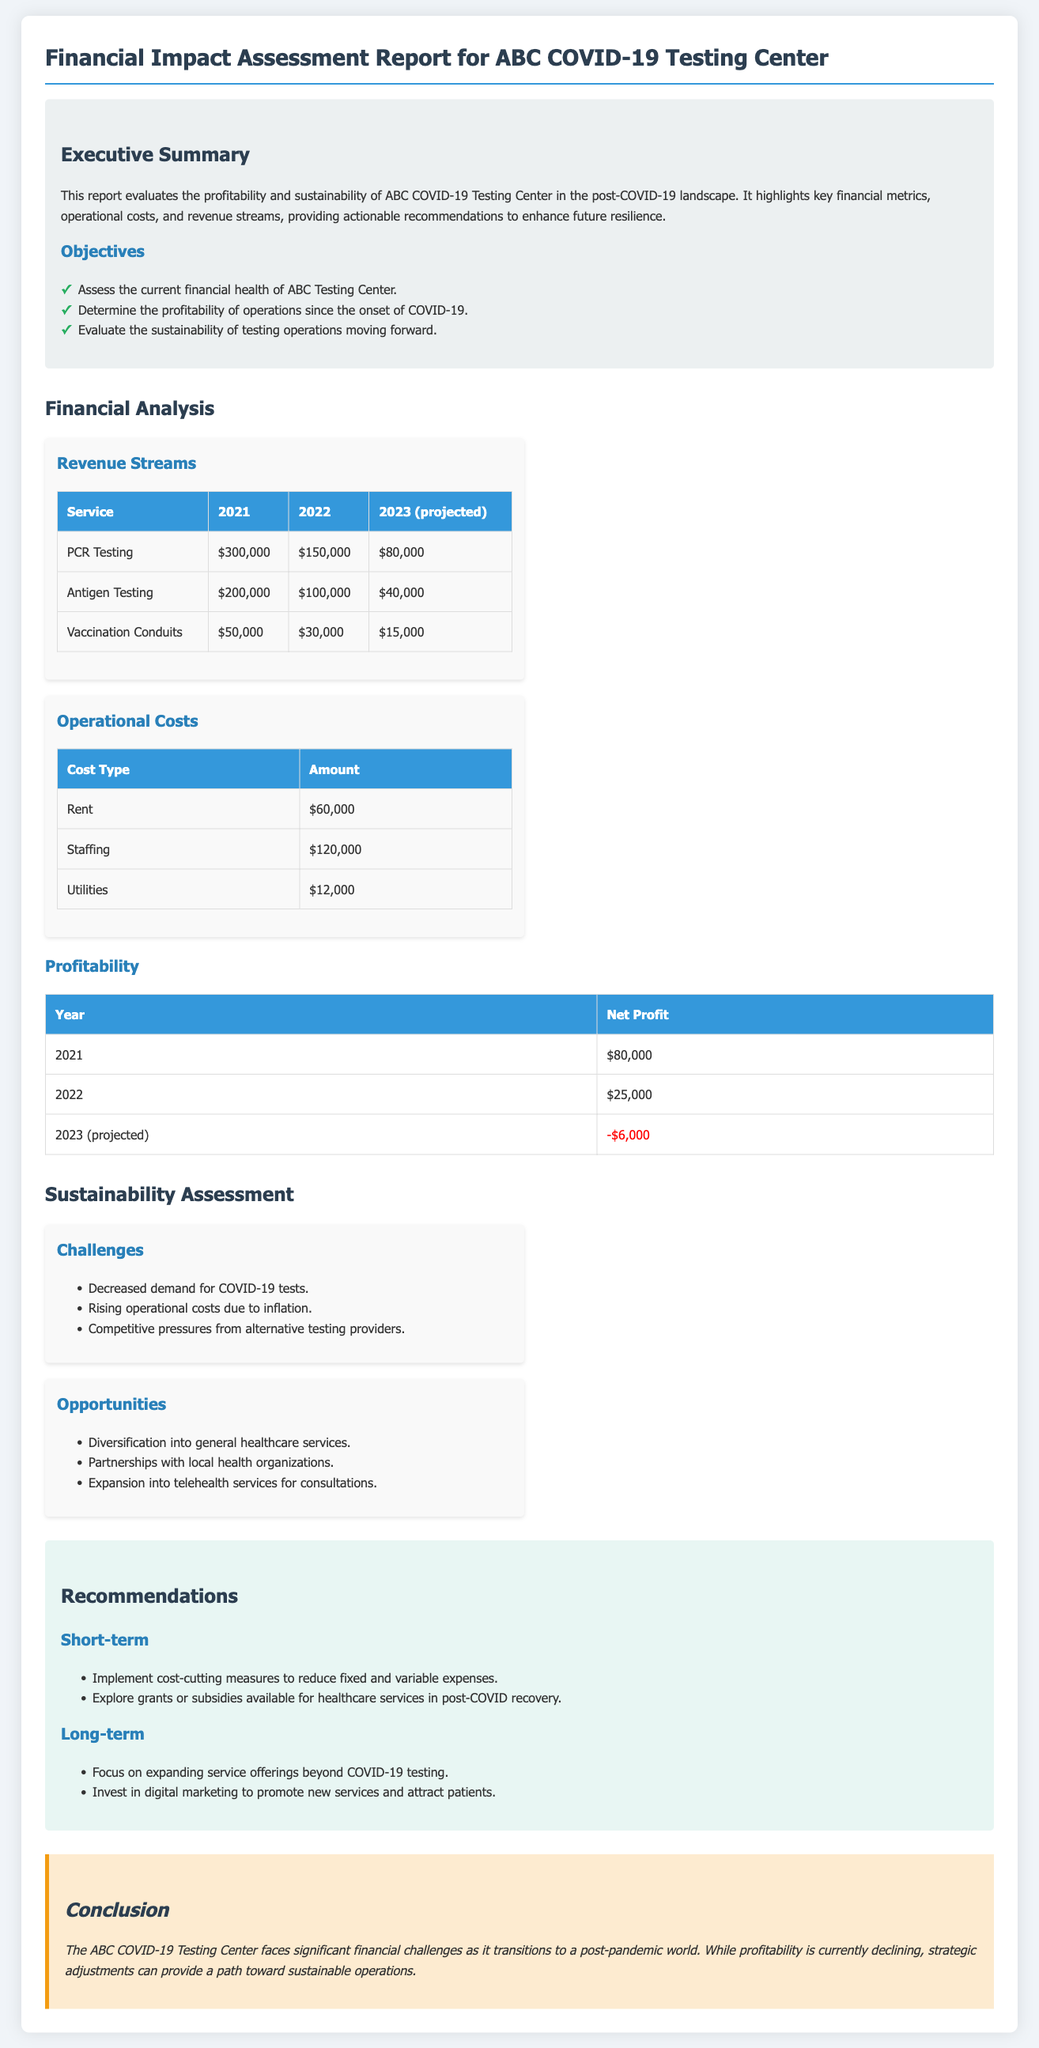what is the net profit for 2021? The net profit for 2021 is directly stated in the document as $80,000.
Answer: $80,000 what was the revenue from PCR testing in 2022? The document provides the revenue from PCR testing for 2022 as $150,000.
Answer: $150,000 what are two identified challenges for sustainability? The document lists challenges such as "Decreased demand for COVID-19 tests" and "Rising operational costs due to inflation".
Answer: Decreased demand for COVID-19 tests, Rising operational costs due to inflation what is the total staffing cost? The staffing cost is given explicitly as $120,000 in the operational costs section of the report.
Answer: $120,000 what is the projected net profit for 2023? The projected net profit for 2023 is indicated as -$6,000, highlighting a loss.
Answer: -$6,000 what are short-term recommendations listed in the report? The report includes recommendations such as "Implement cost-cutting measures" and "Explore grants or subsidies".
Answer: Implement cost-cutting measures, Explore grants or subsidies what is the total revenue from Antigen Testing in 2023? The revenue from Antigen Testing in 2023 is specified as $40,000 in the revenue streams table.
Answer: $40,000 what is the year-over-year trend in net profit from 2021 to 2023? The trend indicates a decrease in net profit, with amounts decreasing from $80,000 to -$6,000 across the years.
Answer: Decrease 